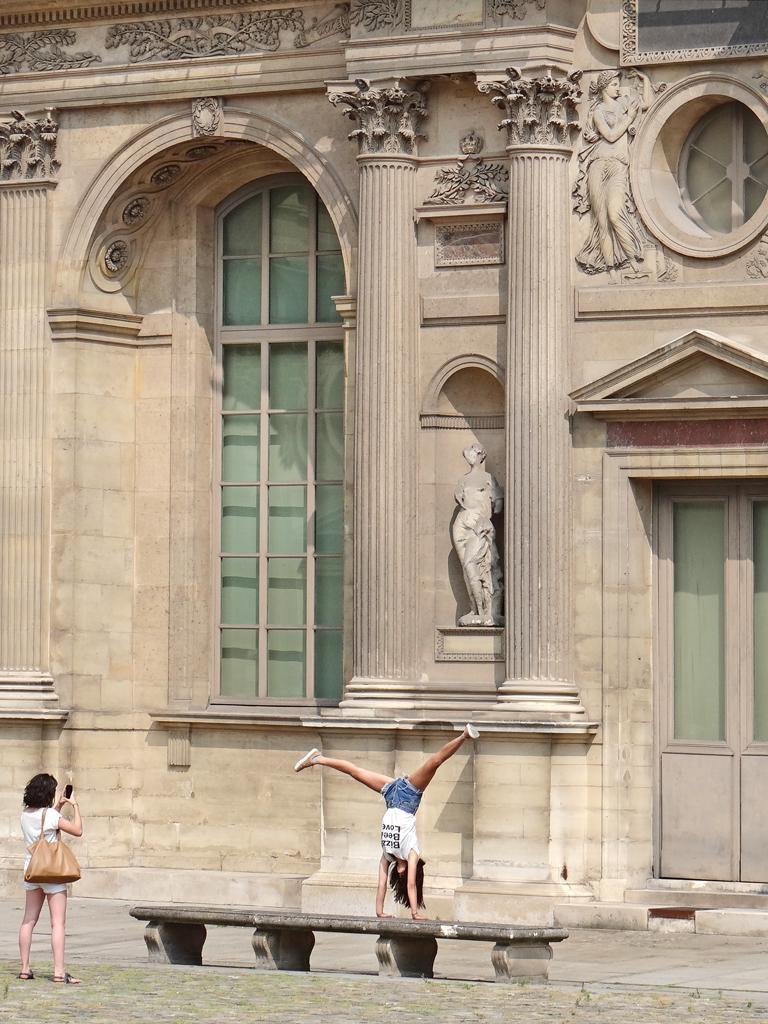Could you give a brief overview of what you see in this image? In the foreground I can see a person is doing a stunt on a bench and one person is standing on grass and is holding an object in hand. In the background I can see sculptures, windows, pillars and a building. This image is taken may be during a day. 